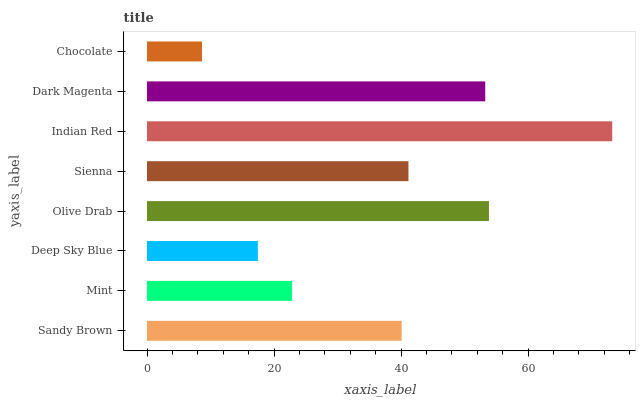Is Chocolate the minimum?
Answer yes or no. Yes. Is Indian Red the maximum?
Answer yes or no. Yes. Is Mint the minimum?
Answer yes or no. No. Is Mint the maximum?
Answer yes or no. No. Is Sandy Brown greater than Mint?
Answer yes or no. Yes. Is Mint less than Sandy Brown?
Answer yes or no. Yes. Is Mint greater than Sandy Brown?
Answer yes or no. No. Is Sandy Brown less than Mint?
Answer yes or no. No. Is Sienna the high median?
Answer yes or no. Yes. Is Sandy Brown the low median?
Answer yes or no. Yes. Is Mint the high median?
Answer yes or no. No. Is Deep Sky Blue the low median?
Answer yes or no. No. 